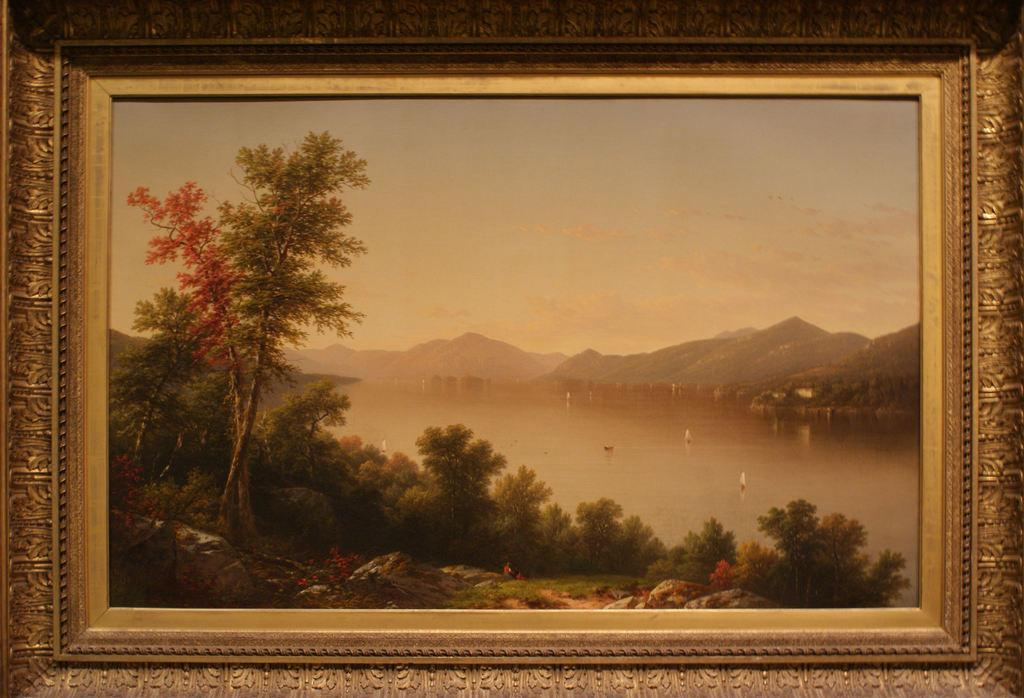What object can be seen in the image? There is a photo frame in the image. What is depicted inside the photo frame? The photo frame contains a scenery. What type of star can be seen on the chin of the person in the image? There is no person present in the image, and therefore no chin or star can be observed. 